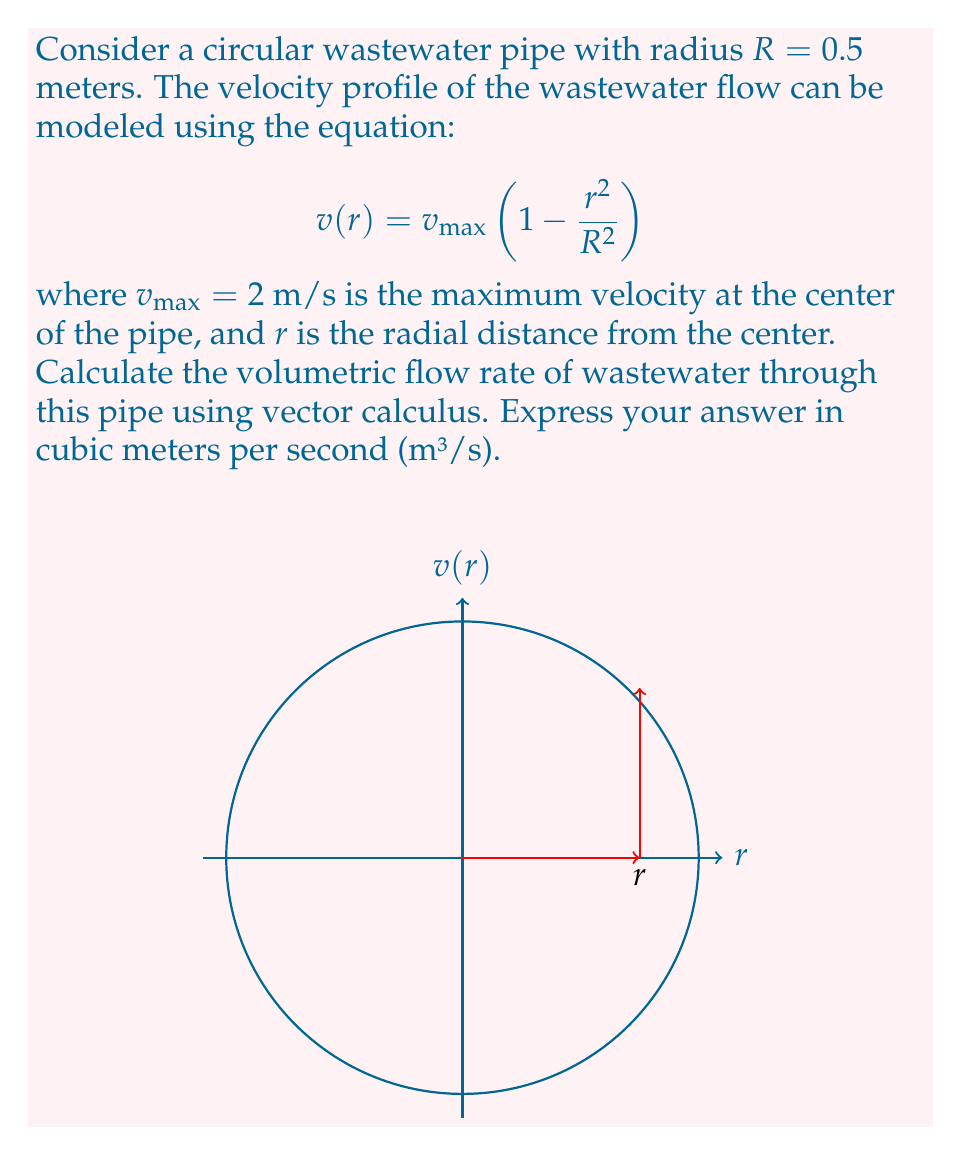Teach me how to tackle this problem. To solve this problem, we'll use the concept of flux from vector calculus. The steps are as follows:

1) The volumetric flow rate is equal to the flux of the velocity vector field across the circular cross-section of the pipe. We can express this using the flux integral:

   $$Q = \iint_S \mathbf{v} \cdot d\mathbf{S}$$

   where $\mathbf{v}$ is the velocity vector field and $d\mathbf{S}$ is the differential area vector.

2) Given the axial symmetry of the pipe, we can simplify this to a single integral in polar coordinates:

   $$Q = \int_0^R v(r) \cdot 2\pi r \, dr$$

3) Substituting the given velocity profile:

   $$Q = \int_0^R v_{max}\left(1 - \frac{r^2}{R^2}\right) \cdot 2\pi r \, dr$$

4) Let's substitute the given values: $v_{max} = 2$ m/s and $R = 0.5$ m:

   $$Q = \int_0^{0.5} 2\left(1 - \frac{r^2}{(0.5)^2}\right) \cdot 2\pi r \, dr$$

5) Simplify:

   $$Q = 4\pi \int_0^{0.5} (1 - 4r^2)r \, dr$$

6) Integrate:

   $$Q = 4\pi \left[
\frac{r^2}{2} - \frac{4r^4}{4}
\right]_0^{0.5}$$

7) Evaluate the integral:

   $$Q = 4\pi \left[
(\frac{(0.5)^2}{2} - \frac{4(0.5)^4}{4}) - (0 - 0)
\right]$$

8) Simplify:

   $$Q = 4\pi (\frac{1}{8} - \frac{1}{16}) = 4\pi \cdot \frac{1}{16} = \frac{\pi}{4}$$

Therefore, the volumetric flow rate is $\frac{\pi}{4}$ m³/s.
Answer: $\frac{\pi}{4}$ m³/s 